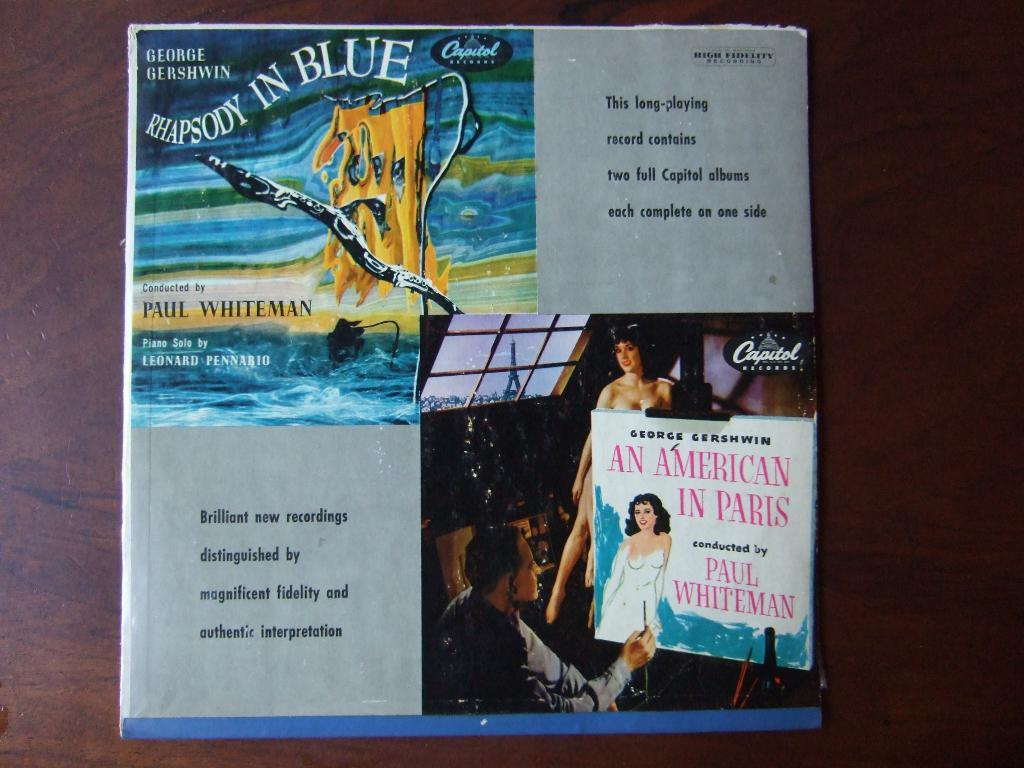<image>
Offer a succinct explanation of the picture presented. A recording of George Gershwin Rhapsody in Blue. 